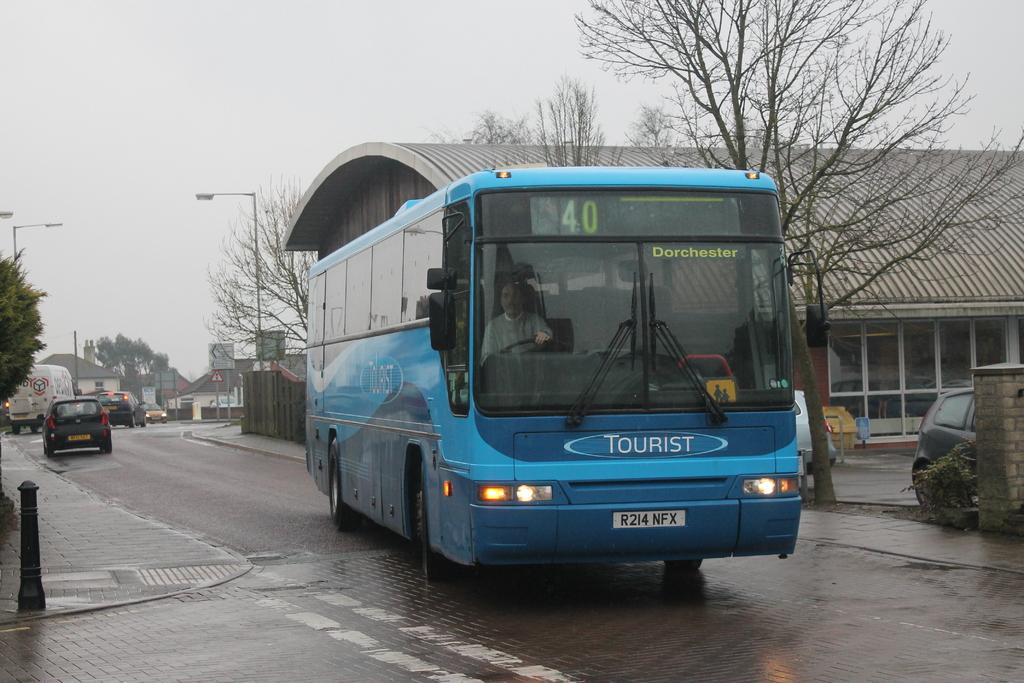<image>
Relay a brief, clear account of the picture shown. a bus has the word tourist on the front 